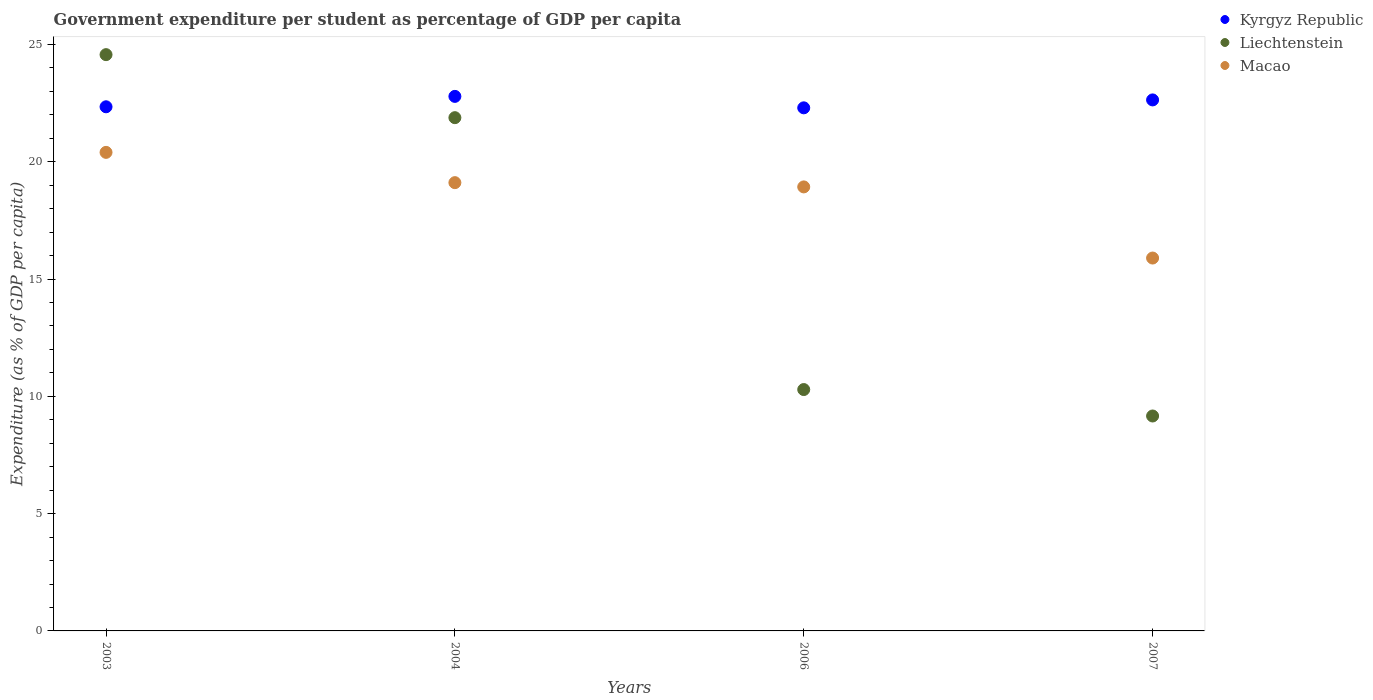How many different coloured dotlines are there?
Provide a short and direct response. 3. Is the number of dotlines equal to the number of legend labels?
Keep it short and to the point. Yes. What is the percentage of expenditure per student in Liechtenstein in 2007?
Offer a terse response. 9.16. Across all years, what is the maximum percentage of expenditure per student in Liechtenstein?
Offer a terse response. 24.57. Across all years, what is the minimum percentage of expenditure per student in Macao?
Your answer should be compact. 15.89. What is the total percentage of expenditure per student in Kyrgyz Republic in the graph?
Offer a very short reply. 90.06. What is the difference between the percentage of expenditure per student in Kyrgyz Republic in 2003 and that in 2006?
Offer a very short reply. 0.04. What is the difference between the percentage of expenditure per student in Liechtenstein in 2006 and the percentage of expenditure per student in Kyrgyz Republic in 2003?
Provide a short and direct response. -12.05. What is the average percentage of expenditure per student in Macao per year?
Give a very brief answer. 18.58. In the year 2003, what is the difference between the percentage of expenditure per student in Liechtenstein and percentage of expenditure per student in Macao?
Give a very brief answer. 4.17. In how many years, is the percentage of expenditure per student in Liechtenstein greater than 21 %?
Provide a succinct answer. 2. What is the ratio of the percentage of expenditure per student in Liechtenstein in 2004 to that in 2006?
Ensure brevity in your answer.  2.13. Is the difference between the percentage of expenditure per student in Liechtenstein in 2003 and 2004 greater than the difference between the percentage of expenditure per student in Macao in 2003 and 2004?
Make the answer very short. Yes. What is the difference between the highest and the second highest percentage of expenditure per student in Liechtenstein?
Provide a succinct answer. 2.69. What is the difference between the highest and the lowest percentage of expenditure per student in Macao?
Provide a short and direct response. 4.5. Is it the case that in every year, the sum of the percentage of expenditure per student in Kyrgyz Republic and percentage of expenditure per student in Macao  is greater than the percentage of expenditure per student in Liechtenstein?
Provide a succinct answer. Yes. Is the percentage of expenditure per student in Liechtenstein strictly greater than the percentage of expenditure per student in Macao over the years?
Offer a terse response. No. Is the percentage of expenditure per student in Macao strictly less than the percentage of expenditure per student in Kyrgyz Republic over the years?
Offer a very short reply. Yes. How many dotlines are there?
Make the answer very short. 3. What is the difference between two consecutive major ticks on the Y-axis?
Your answer should be compact. 5. How are the legend labels stacked?
Keep it short and to the point. Vertical. What is the title of the graph?
Give a very brief answer. Government expenditure per student as percentage of GDP per capita. Does "Turkey" appear as one of the legend labels in the graph?
Your answer should be compact. No. What is the label or title of the X-axis?
Your answer should be very brief. Years. What is the label or title of the Y-axis?
Make the answer very short. Expenditure (as % of GDP per capita). What is the Expenditure (as % of GDP per capita) of Kyrgyz Republic in 2003?
Your response must be concise. 22.34. What is the Expenditure (as % of GDP per capita) of Liechtenstein in 2003?
Make the answer very short. 24.57. What is the Expenditure (as % of GDP per capita) of Macao in 2003?
Give a very brief answer. 20.4. What is the Expenditure (as % of GDP per capita) in Kyrgyz Republic in 2004?
Your response must be concise. 22.79. What is the Expenditure (as % of GDP per capita) of Liechtenstein in 2004?
Your answer should be very brief. 21.88. What is the Expenditure (as % of GDP per capita) in Macao in 2004?
Your answer should be compact. 19.11. What is the Expenditure (as % of GDP per capita) in Kyrgyz Republic in 2006?
Your response must be concise. 22.3. What is the Expenditure (as % of GDP per capita) in Liechtenstein in 2006?
Make the answer very short. 10.29. What is the Expenditure (as % of GDP per capita) in Macao in 2006?
Give a very brief answer. 18.93. What is the Expenditure (as % of GDP per capita) in Kyrgyz Republic in 2007?
Give a very brief answer. 22.64. What is the Expenditure (as % of GDP per capita) of Liechtenstein in 2007?
Offer a very short reply. 9.16. What is the Expenditure (as % of GDP per capita) in Macao in 2007?
Make the answer very short. 15.89. Across all years, what is the maximum Expenditure (as % of GDP per capita) of Kyrgyz Republic?
Provide a succinct answer. 22.79. Across all years, what is the maximum Expenditure (as % of GDP per capita) of Liechtenstein?
Keep it short and to the point. 24.57. Across all years, what is the maximum Expenditure (as % of GDP per capita) in Macao?
Your answer should be very brief. 20.4. Across all years, what is the minimum Expenditure (as % of GDP per capita) of Kyrgyz Republic?
Your response must be concise. 22.3. Across all years, what is the minimum Expenditure (as % of GDP per capita) of Liechtenstein?
Provide a short and direct response. 9.16. Across all years, what is the minimum Expenditure (as % of GDP per capita) of Macao?
Provide a short and direct response. 15.89. What is the total Expenditure (as % of GDP per capita) of Kyrgyz Republic in the graph?
Your response must be concise. 90.06. What is the total Expenditure (as % of GDP per capita) of Liechtenstein in the graph?
Keep it short and to the point. 65.89. What is the total Expenditure (as % of GDP per capita) in Macao in the graph?
Offer a very short reply. 74.33. What is the difference between the Expenditure (as % of GDP per capita) in Kyrgyz Republic in 2003 and that in 2004?
Your answer should be compact. -0.44. What is the difference between the Expenditure (as % of GDP per capita) in Liechtenstein in 2003 and that in 2004?
Make the answer very short. 2.69. What is the difference between the Expenditure (as % of GDP per capita) of Macao in 2003 and that in 2004?
Provide a succinct answer. 1.29. What is the difference between the Expenditure (as % of GDP per capita) in Kyrgyz Republic in 2003 and that in 2006?
Offer a very short reply. 0.04. What is the difference between the Expenditure (as % of GDP per capita) in Liechtenstein in 2003 and that in 2006?
Make the answer very short. 14.28. What is the difference between the Expenditure (as % of GDP per capita) in Macao in 2003 and that in 2006?
Your answer should be very brief. 1.47. What is the difference between the Expenditure (as % of GDP per capita) of Kyrgyz Republic in 2003 and that in 2007?
Your answer should be very brief. -0.29. What is the difference between the Expenditure (as % of GDP per capita) of Liechtenstein in 2003 and that in 2007?
Offer a very short reply. 15.4. What is the difference between the Expenditure (as % of GDP per capita) of Macao in 2003 and that in 2007?
Your answer should be compact. 4.5. What is the difference between the Expenditure (as % of GDP per capita) in Kyrgyz Republic in 2004 and that in 2006?
Offer a terse response. 0.49. What is the difference between the Expenditure (as % of GDP per capita) of Liechtenstein in 2004 and that in 2006?
Your answer should be very brief. 11.59. What is the difference between the Expenditure (as % of GDP per capita) of Macao in 2004 and that in 2006?
Provide a short and direct response. 0.18. What is the difference between the Expenditure (as % of GDP per capita) in Kyrgyz Republic in 2004 and that in 2007?
Make the answer very short. 0.15. What is the difference between the Expenditure (as % of GDP per capita) in Liechtenstein in 2004 and that in 2007?
Keep it short and to the point. 12.72. What is the difference between the Expenditure (as % of GDP per capita) in Macao in 2004 and that in 2007?
Provide a succinct answer. 3.21. What is the difference between the Expenditure (as % of GDP per capita) of Kyrgyz Republic in 2006 and that in 2007?
Provide a short and direct response. -0.34. What is the difference between the Expenditure (as % of GDP per capita) in Liechtenstein in 2006 and that in 2007?
Your response must be concise. 1.13. What is the difference between the Expenditure (as % of GDP per capita) of Macao in 2006 and that in 2007?
Make the answer very short. 3.03. What is the difference between the Expenditure (as % of GDP per capita) in Kyrgyz Republic in 2003 and the Expenditure (as % of GDP per capita) in Liechtenstein in 2004?
Provide a succinct answer. 0.46. What is the difference between the Expenditure (as % of GDP per capita) of Kyrgyz Republic in 2003 and the Expenditure (as % of GDP per capita) of Macao in 2004?
Your answer should be very brief. 3.23. What is the difference between the Expenditure (as % of GDP per capita) of Liechtenstein in 2003 and the Expenditure (as % of GDP per capita) of Macao in 2004?
Your answer should be very brief. 5.46. What is the difference between the Expenditure (as % of GDP per capita) in Kyrgyz Republic in 2003 and the Expenditure (as % of GDP per capita) in Liechtenstein in 2006?
Your response must be concise. 12.05. What is the difference between the Expenditure (as % of GDP per capita) of Kyrgyz Republic in 2003 and the Expenditure (as % of GDP per capita) of Macao in 2006?
Offer a very short reply. 3.42. What is the difference between the Expenditure (as % of GDP per capita) in Liechtenstein in 2003 and the Expenditure (as % of GDP per capita) in Macao in 2006?
Give a very brief answer. 5.64. What is the difference between the Expenditure (as % of GDP per capita) of Kyrgyz Republic in 2003 and the Expenditure (as % of GDP per capita) of Liechtenstein in 2007?
Your answer should be compact. 13.18. What is the difference between the Expenditure (as % of GDP per capita) of Kyrgyz Republic in 2003 and the Expenditure (as % of GDP per capita) of Macao in 2007?
Give a very brief answer. 6.45. What is the difference between the Expenditure (as % of GDP per capita) in Liechtenstein in 2003 and the Expenditure (as % of GDP per capita) in Macao in 2007?
Provide a short and direct response. 8.67. What is the difference between the Expenditure (as % of GDP per capita) of Kyrgyz Republic in 2004 and the Expenditure (as % of GDP per capita) of Liechtenstein in 2006?
Offer a terse response. 12.5. What is the difference between the Expenditure (as % of GDP per capita) of Kyrgyz Republic in 2004 and the Expenditure (as % of GDP per capita) of Macao in 2006?
Offer a terse response. 3.86. What is the difference between the Expenditure (as % of GDP per capita) in Liechtenstein in 2004 and the Expenditure (as % of GDP per capita) in Macao in 2006?
Provide a succinct answer. 2.95. What is the difference between the Expenditure (as % of GDP per capita) of Kyrgyz Republic in 2004 and the Expenditure (as % of GDP per capita) of Liechtenstein in 2007?
Your answer should be very brief. 13.62. What is the difference between the Expenditure (as % of GDP per capita) of Kyrgyz Republic in 2004 and the Expenditure (as % of GDP per capita) of Macao in 2007?
Your answer should be very brief. 6.89. What is the difference between the Expenditure (as % of GDP per capita) in Liechtenstein in 2004 and the Expenditure (as % of GDP per capita) in Macao in 2007?
Keep it short and to the point. 5.98. What is the difference between the Expenditure (as % of GDP per capita) of Kyrgyz Republic in 2006 and the Expenditure (as % of GDP per capita) of Liechtenstein in 2007?
Your response must be concise. 13.14. What is the difference between the Expenditure (as % of GDP per capita) in Kyrgyz Republic in 2006 and the Expenditure (as % of GDP per capita) in Macao in 2007?
Offer a very short reply. 6.4. What is the difference between the Expenditure (as % of GDP per capita) of Liechtenstein in 2006 and the Expenditure (as % of GDP per capita) of Macao in 2007?
Make the answer very short. -5.61. What is the average Expenditure (as % of GDP per capita) in Kyrgyz Republic per year?
Offer a very short reply. 22.52. What is the average Expenditure (as % of GDP per capita) in Liechtenstein per year?
Make the answer very short. 16.47. What is the average Expenditure (as % of GDP per capita) in Macao per year?
Provide a short and direct response. 18.58. In the year 2003, what is the difference between the Expenditure (as % of GDP per capita) in Kyrgyz Republic and Expenditure (as % of GDP per capita) in Liechtenstein?
Provide a short and direct response. -2.22. In the year 2003, what is the difference between the Expenditure (as % of GDP per capita) in Kyrgyz Republic and Expenditure (as % of GDP per capita) in Macao?
Make the answer very short. 1.94. In the year 2003, what is the difference between the Expenditure (as % of GDP per capita) in Liechtenstein and Expenditure (as % of GDP per capita) in Macao?
Your answer should be compact. 4.17. In the year 2004, what is the difference between the Expenditure (as % of GDP per capita) of Kyrgyz Republic and Expenditure (as % of GDP per capita) of Liechtenstein?
Provide a short and direct response. 0.91. In the year 2004, what is the difference between the Expenditure (as % of GDP per capita) of Kyrgyz Republic and Expenditure (as % of GDP per capita) of Macao?
Your answer should be very brief. 3.68. In the year 2004, what is the difference between the Expenditure (as % of GDP per capita) in Liechtenstein and Expenditure (as % of GDP per capita) in Macao?
Offer a terse response. 2.77. In the year 2006, what is the difference between the Expenditure (as % of GDP per capita) in Kyrgyz Republic and Expenditure (as % of GDP per capita) in Liechtenstein?
Keep it short and to the point. 12.01. In the year 2006, what is the difference between the Expenditure (as % of GDP per capita) of Kyrgyz Republic and Expenditure (as % of GDP per capita) of Macao?
Provide a succinct answer. 3.37. In the year 2006, what is the difference between the Expenditure (as % of GDP per capita) of Liechtenstein and Expenditure (as % of GDP per capita) of Macao?
Provide a short and direct response. -8.64. In the year 2007, what is the difference between the Expenditure (as % of GDP per capita) of Kyrgyz Republic and Expenditure (as % of GDP per capita) of Liechtenstein?
Make the answer very short. 13.47. In the year 2007, what is the difference between the Expenditure (as % of GDP per capita) in Kyrgyz Republic and Expenditure (as % of GDP per capita) in Macao?
Your response must be concise. 6.74. In the year 2007, what is the difference between the Expenditure (as % of GDP per capita) in Liechtenstein and Expenditure (as % of GDP per capita) in Macao?
Keep it short and to the point. -6.73. What is the ratio of the Expenditure (as % of GDP per capita) of Kyrgyz Republic in 2003 to that in 2004?
Your answer should be very brief. 0.98. What is the ratio of the Expenditure (as % of GDP per capita) in Liechtenstein in 2003 to that in 2004?
Your response must be concise. 1.12. What is the ratio of the Expenditure (as % of GDP per capita) in Macao in 2003 to that in 2004?
Keep it short and to the point. 1.07. What is the ratio of the Expenditure (as % of GDP per capita) in Liechtenstein in 2003 to that in 2006?
Offer a very short reply. 2.39. What is the ratio of the Expenditure (as % of GDP per capita) in Macao in 2003 to that in 2006?
Provide a succinct answer. 1.08. What is the ratio of the Expenditure (as % of GDP per capita) of Kyrgyz Republic in 2003 to that in 2007?
Ensure brevity in your answer.  0.99. What is the ratio of the Expenditure (as % of GDP per capita) in Liechtenstein in 2003 to that in 2007?
Keep it short and to the point. 2.68. What is the ratio of the Expenditure (as % of GDP per capita) of Macao in 2003 to that in 2007?
Provide a succinct answer. 1.28. What is the ratio of the Expenditure (as % of GDP per capita) of Kyrgyz Republic in 2004 to that in 2006?
Provide a succinct answer. 1.02. What is the ratio of the Expenditure (as % of GDP per capita) in Liechtenstein in 2004 to that in 2006?
Keep it short and to the point. 2.13. What is the ratio of the Expenditure (as % of GDP per capita) in Macao in 2004 to that in 2006?
Offer a very short reply. 1.01. What is the ratio of the Expenditure (as % of GDP per capita) in Kyrgyz Republic in 2004 to that in 2007?
Offer a terse response. 1.01. What is the ratio of the Expenditure (as % of GDP per capita) of Liechtenstein in 2004 to that in 2007?
Make the answer very short. 2.39. What is the ratio of the Expenditure (as % of GDP per capita) in Macao in 2004 to that in 2007?
Your response must be concise. 1.2. What is the ratio of the Expenditure (as % of GDP per capita) in Kyrgyz Republic in 2006 to that in 2007?
Your response must be concise. 0.99. What is the ratio of the Expenditure (as % of GDP per capita) of Liechtenstein in 2006 to that in 2007?
Offer a very short reply. 1.12. What is the ratio of the Expenditure (as % of GDP per capita) of Macao in 2006 to that in 2007?
Your answer should be very brief. 1.19. What is the difference between the highest and the second highest Expenditure (as % of GDP per capita) in Kyrgyz Republic?
Ensure brevity in your answer.  0.15. What is the difference between the highest and the second highest Expenditure (as % of GDP per capita) of Liechtenstein?
Offer a terse response. 2.69. What is the difference between the highest and the second highest Expenditure (as % of GDP per capita) of Macao?
Make the answer very short. 1.29. What is the difference between the highest and the lowest Expenditure (as % of GDP per capita) of Kyrgyz Republic?
Keep it short and to the point. 0.49. What is the difference between the highest and the lowest Expenditure (as % of GDP per capita) in Liechtenstein?
Ensure brevity in your answer.  15.4. What is the difference between the highest and the lowest Expenditure (as % of GDP per capita) of Macao?
Ensure brevity in your answer.  4.5. 